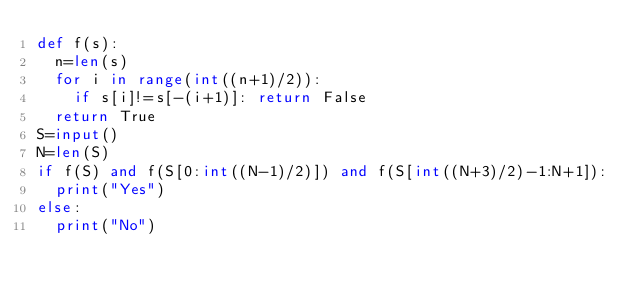Convert code to text. <code><loc_0><loc_0><loc_500><loc_500><_Python_>def f(s):
  n=len(s)
  for i in range(int((n+1)/2)):
    if s[i]!=s[-(i+1)]: return False
  return True
S=input()
N=len(S)
if f(S) and f(S[0:int((N-1)/2)]) and f(S[int((N+3)/2)-1:N+1]):
  print("Yes")
else:
  print("No")</code> 